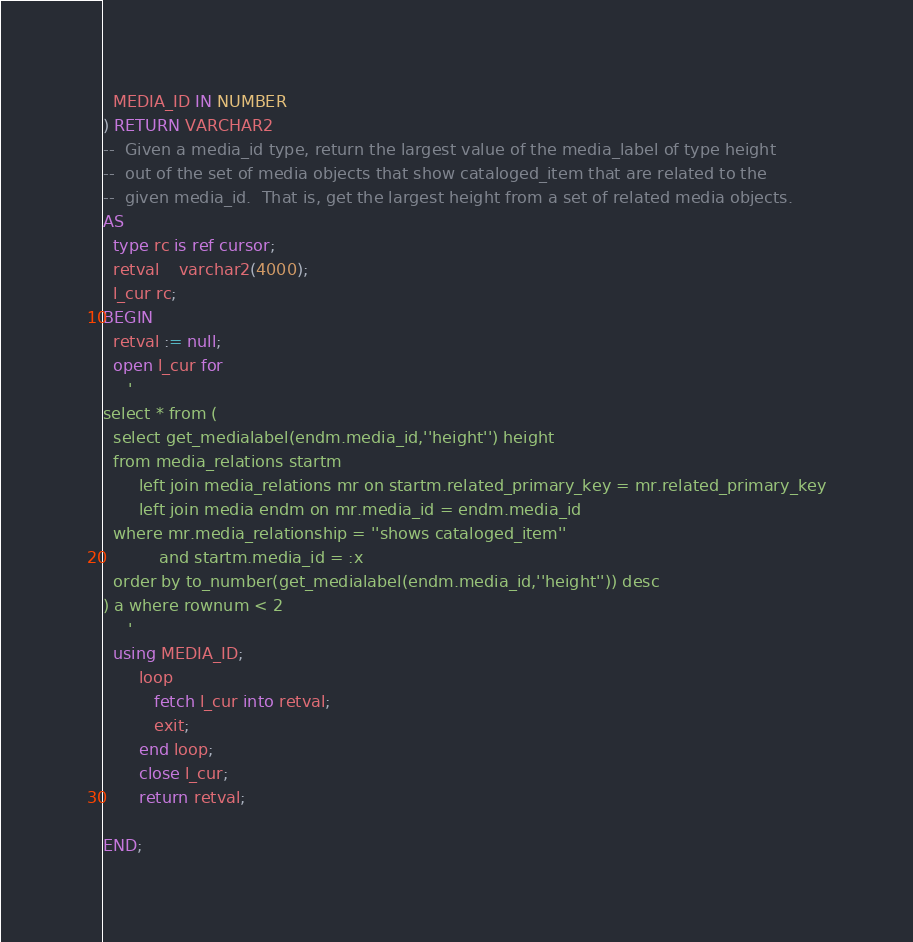Convert code to text. <code><loc_0><loc_0><loc_500><loc_500><_SQL_>  MEDIA_ID IN NUMBER 
) RETURN VARCHAR2 
--  Given a media_id type, return the largest value of the media_label of type height
--  out of the set of media objects that show cataloged_item that are related to the
--  given media_id.  That is, get the largest height from a set of related media objects.
AS 
  type rc is ref cursor;
  retval    varchar2(4000);
  l_cur rc;
BEGIN
  retval := null;
  open l_cur for 
     ' 
select * from (     
  select get_medialabel(endm.media_id,''height'') height
  from media_relations startm 
       left join media_relations mr on startm.related_primary_key = mr.related_primary_key
       left join media endm on mr.media_id = endm.media_id
  where mr.media_relationship = ''shows cataloged_item''
		   and startm.media_id = :x
  order by to_number(get_medialabel(endm.media_id,''height'')) desc     
) a where rownum < 2
     '
  using MEDIA_ID; 
       loop 
          fetch l_cur into retval;
          exit;
       end loop;   
       close l_cur;
       return retval;
  
END;</code> 